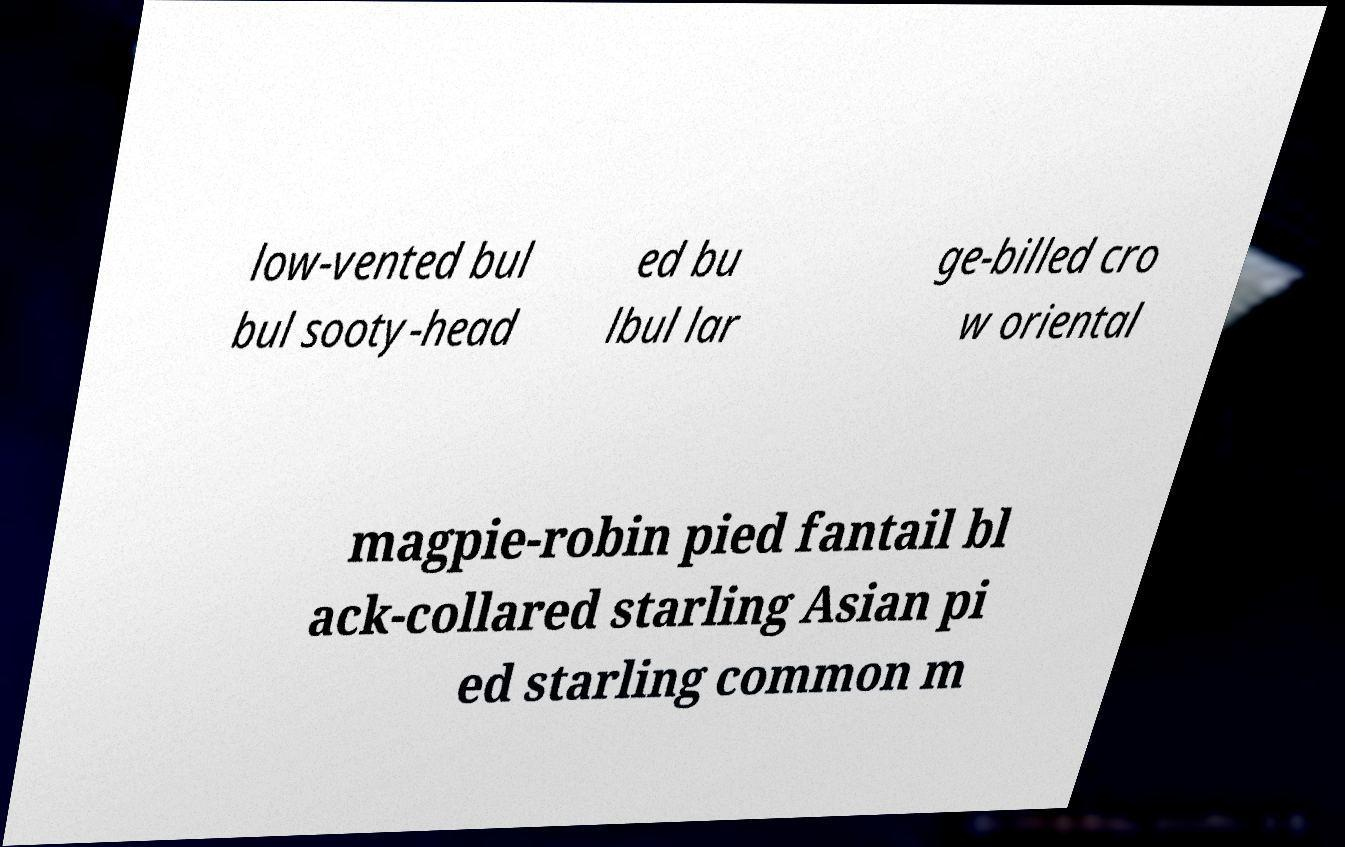What messages or text are displayed in this image? I need them in a readable, typed format. low-vented bul bul sooty-head ed bu lbul lar ge-billed cro w oriental magpie-robin pied fantail bl ack-collared starling Asian pi ed starling common m 